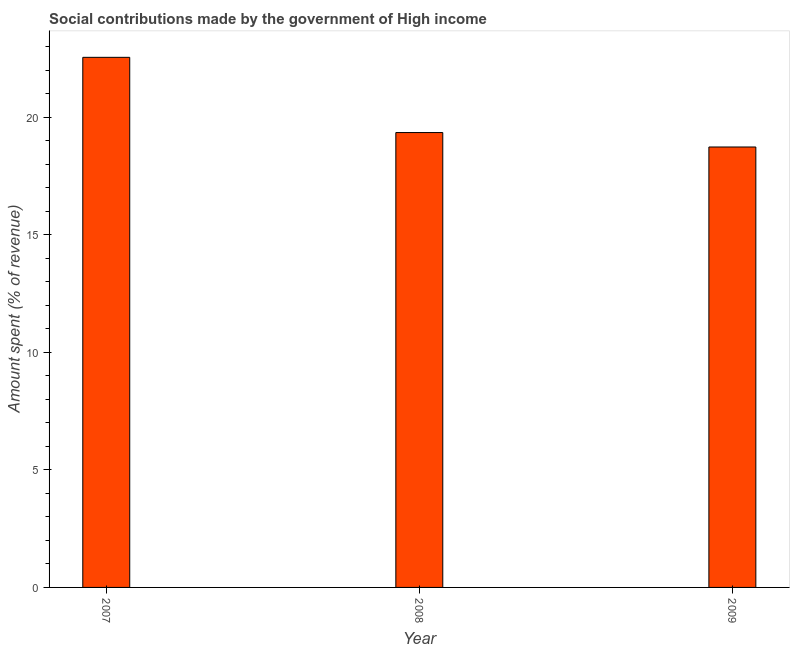Does the graph contain any zero values?
Your answer should be very brief. No. What is the title of the graph?
Your answer should be very brief. Social contributions made by the government of High income. What is the label or title of the Y-axis?
Provide a succinct answer. Amount spent (% of revenue). What is the amount spent in making social contributions in 2008?
Keep it short and to the point. 19.35. Across all years, what is the maximum amount spent in making social contributions?
Your answer should be compact. 22.55. Across all years, what is the minimum amount spent in making social contributions?
Your answer should be very brief. 18.74. What is the sum of the amount spent in making social contributions?
Ensure brevity in your answer.  60.64. What is the difference between the amount spent in making social contributions in 2008 and 2009?
Provide a short and direct response. 0.61. What is the average amount spent in making social contributions per year?
Offer a very short reply. 20.21. What is the median amount spent in making social contributions?
Your response must be concise. 19.35. Do a majority of the years between 2008 and 2009 (inclusive) have amount spent in making social contributions greater than 16 %?
Offer a terse response. Yes. What is the ratio of the amount spent in making social contributions in 2007 to that in 2009?
Your answer should be compact. 1.2. Is the amount spent in making social contributions in 2008 less than that in 2009?
Provide a succinct answer. No. Is the difference between the amount spent in making social contributions in 2008 and 2009 greater than the difference between any two years?
Your answer should be very brief. No. What is the difference between the highest and the second highest amount spent in making social contributions?
Your response must be concise. 3.2. Is the sum of the amount spent in making social contributions in 2007 and 2009 greater than the maximum amount spent in making social contributions across all years?
Your response must be concise. Yes. What is the difference between the highest and the lowest amount spent in making social contributions?
Your answer should be compact. 3.81. How many years are there in the graph?
Your answer should be very brief. 3. What is the difference between two consecutive major ticks on the Y-axis?
Give a very brief answer. 5. Are the values on the major ticks of Y-axis written in scientific E-notation?
Provide a succinct answer. No. What is the Amount spent (% of revenue) in 2007?
Your answer should be compact. 22.55. What is the Amount spent (% of revenue) of 2008?
Provide a short and direct response. 19.35. What is the Amount spent (% of revenue) in 2009?
Provide a short and direct response. 18.74. What is the difference between the Amount spent (% of revenue) in 2007 and 2008?
Your answer should be very brief. 3.2. What is the difference between the Amount spent (% of revenue) in 2007 and 2009?
Offer a very short reply. 3.81. What is the difference between the Amount spent (% of revenue) in 2008 and 2009?
Give a very brief answer. 0.61. What is the ratio of the Amount spent (% of revenue) in 2007 to that in 2008?
Ensure brevity in your answer.  1.17. What is the ratio of the Amount spent (% of revenue) in 2007 to that in 2009?
Ensure brevity in your answer.  1.2. What is the ratio of the Amount spent (% of revenue) in 2008 to that in 2009?
Provide a succinct answer. 1.03. 